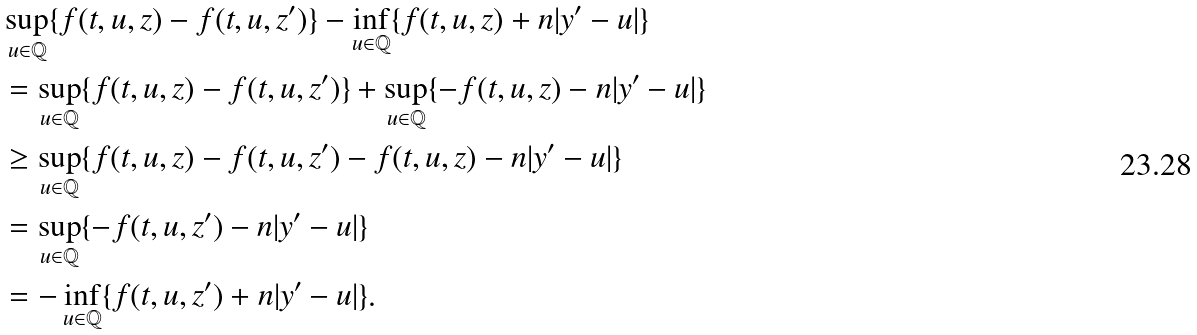<formula> <loc_0><loc_0><loc_500><loc_500>& \sup _ { u \in \mathbb { Q } } \{ f ( t , u , z ) - f ( t , u , z ^ { \prime } ) \} - \inf _ { u \in \mathbb { Q } } \{ f ( t , u , z ) + n | y ^ { \prime } - u | \} \\ & = \sup _ { u \in \mathbb { Q } } \{ f ( t , u , z ) - f ( t , u , z ^ { \prime } ) \} + \sup _ { u \in \mathbb { Q } } \{ - f ( t , u , z ) - n | y ^ { \prime } - u | \} \\ & \geq \sup _ { u \in \mathbb { Q } } \{ f ( t , u , z ) - f ( t , u , z ^ { \prime } ) - f ( t , u , z ) - n | y ^ { \prime } - u | \} \\ & = \sup _ { u \in \mathbb { Q } } \{ - f ( t , u , z ^ { \prime } ) - n | y ^ { \prime } - u | \} \\ & = - \inf _ { u \in \mathbb { Q } } \{ f ( t , u , z ^ { \prime } ) + n | y ^ { \prime } - u | \} .</formula> 